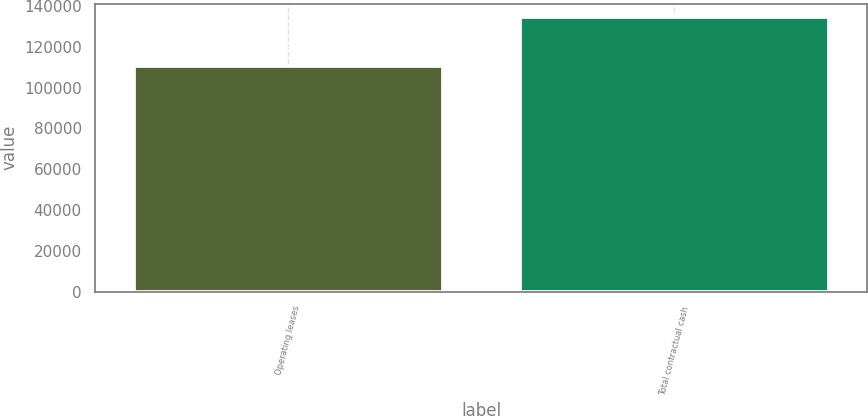Convert chart. <chart><loc_0><loc_0><loc_500><loc_500><bar_chart><fcel>Operating leases<fcel>Total contractual cash<nl><fcel>110526<fcel>134509<nl></chart> 